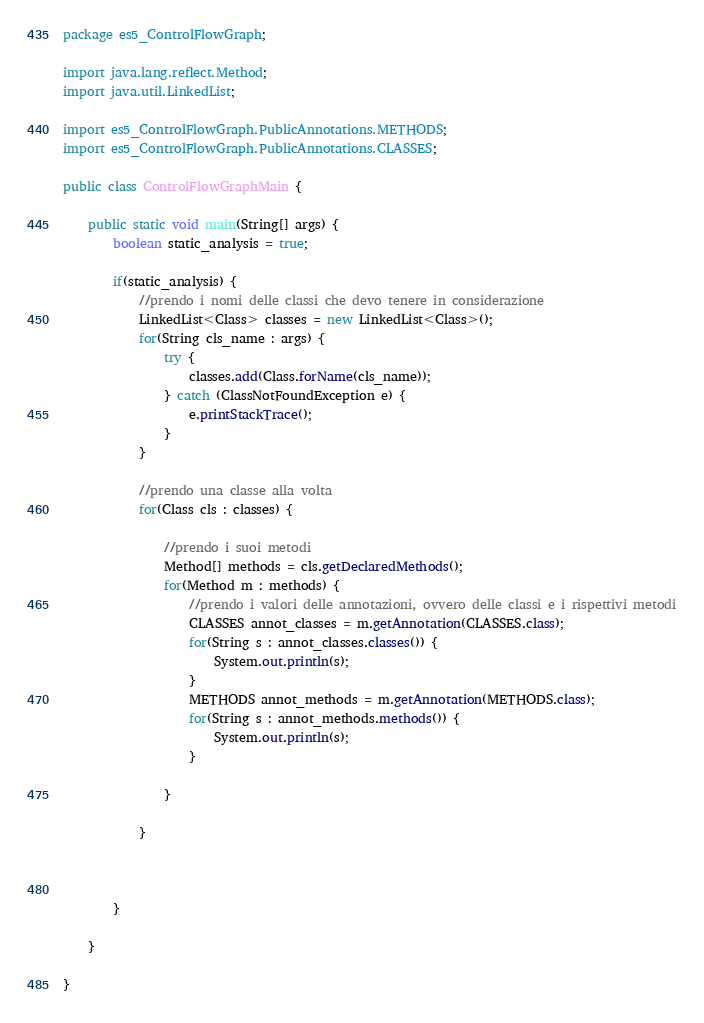Convert code to text. <code><loc_0><loc_0><loc_500><loc_500><_Java_>package es5_ControlFlowGraph;

import java.lang.reflect.Method;
import java.util.LinkedList;

import es5_ControlFlowGraph.PublicAnnotations.METHODS;
import es5_ControlFlowGraph.PublicAnnotations.CLASSES;

public class ControlFlowGraphMain {

	public static void main(String[] args) {
		boolean static_analysis = true;
		
		if(static_analysis) {
			//prendo i nomi delle classi che devo tenere in considerazione
			LinkedList<Class> classes = new LinkedList<Class>();
			for(String cls_name : args) {
				try {
					classes.add(Class.forName(cls_name));
				} catch (ClassNotFoundException e) {
					e.printStackTrace();
				}
			}
			
			//prendo una classe alla volta
			for(Class cls : classes) {
				
				//prendo i suoi metodi
				Method[] methods = cls.getDeclaredMethods();
				for(Method m : methods) {
					//prendo i valori delle annotazioni, ovvero delle classi e i rispettivi metodi
					CLASSES annot_classes = m.getAnnotation(CLASSES.class);
					for(String s : annot_classes.classes()) {
						System.out.println(s);
					}
					METHODS annot_methods = m.getAnnotation(METHODS.class);
					for(String s : annot_methods.methods()) {
						System.out.println(s);
					}
					
				}
				
			}
			
			
			
		}

	}

}
</code> 